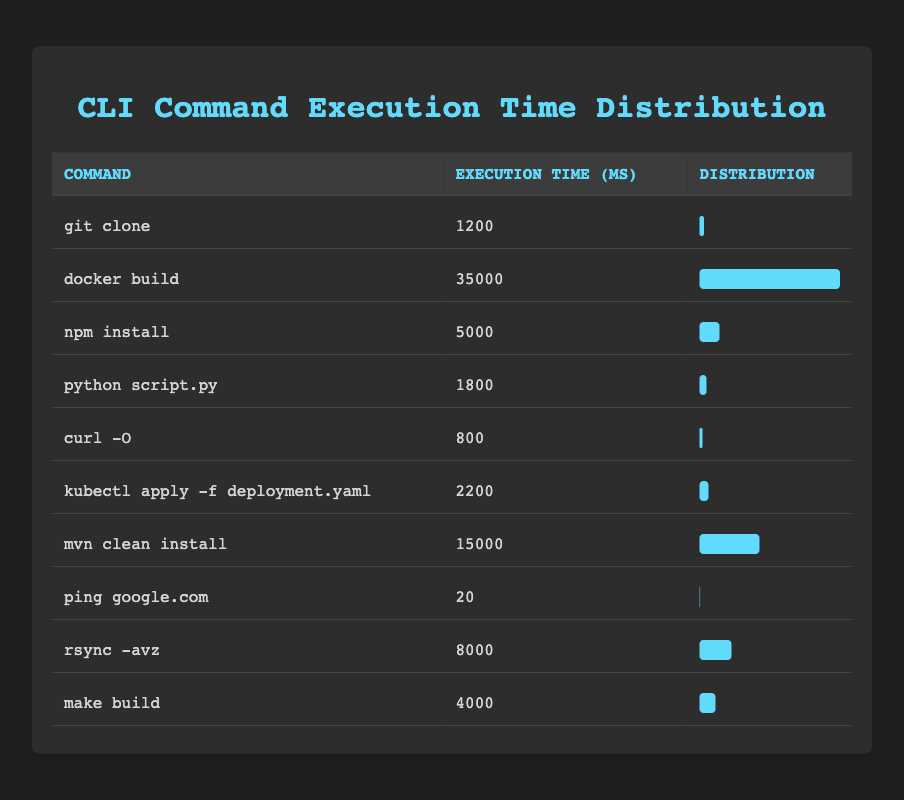What command has the longest execution time? By inspecting the table, the command with the highest execution time is "docker build" with an execution time of 35000 milliseconds.
Answer: docker build What is the execution time of the command "rsync -avz"? The table shows that the execution time for the command "rsync -avz" is 8000 milliseconds.
Answer: 8000 Is the execution time of "ping google.com" less than 100 milliseconds? The table lists "ping google.com" as having an execution time of 20 milliseconds, which is indeed less than 100 milliseconds.
Answer: Yes What is the average execution time of all commands listed? First, sum all the execution times: 1200 + 35000 + 5000 + 1800 + 800 + 2200 + 15000 + 20 + 8000 + 4000 = 58500 milliseconds. Divide this total by the number of commands (10), so the average is 58500 / 10 = 5850 milliseconds.
Answer: 5850 Which command has an execution time that is closest to the average execution time? The average execution time is found to be 5850 milliseconds. Next, I compare each execution time to see which is closest. "npm install" at 5000 milliseconds is closest, being just 850 milliseconds below the average.
Answer: npm install How many commands have execution times greater than 2000 milliseconds? By reviewing the table: "docker build," "npm install," "mvn clean install," "kubectl apply -f deployment.yaml," "git clone," "rsync -avz," and "make build." In total, 6 commands have execution times greater than 2000 milliseconds.
Answer: 6 Is "curl -O" the fastest command listed? The execution time for "curl -O" is 800 milliseconds, and when comparing this with all other commands, none have a lower execution time, thus affirming that it is indeed the fastest.
Answer: Yes What is the difference in execution time between the fastest and the slowest command? The fastest command is "ping google.com" with 20 milliseconds, and the slowest is "docker build" with 35000 milliseconds. Thus, the difference is calculated as 35000 - 20 = 34980 milliseconds.
Answer: 34980 